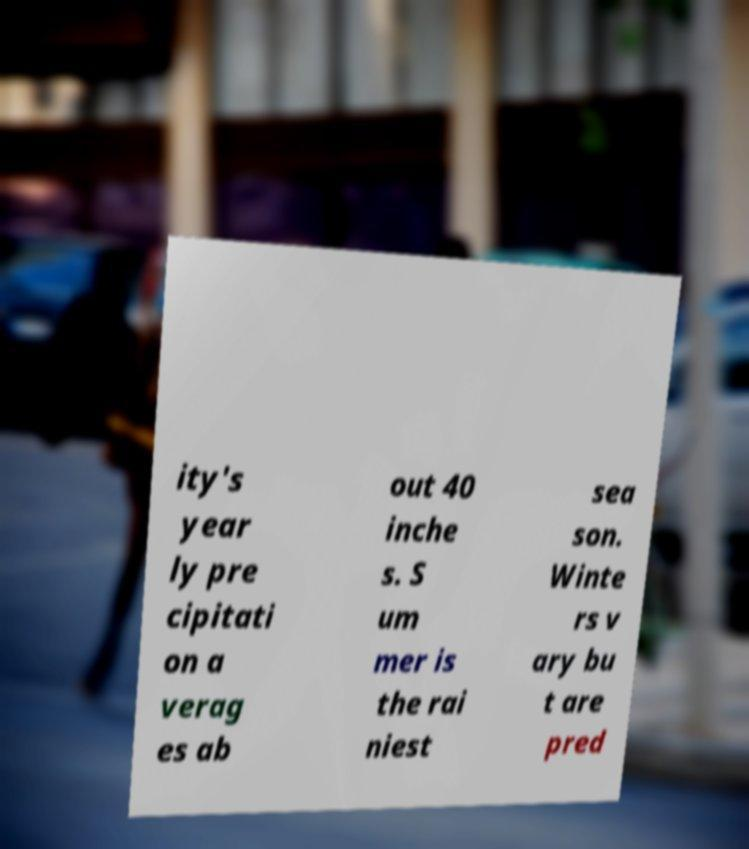There's text embedded in this image that I need extracted. Can you transcribe it verbatim? ity's year ly pre cipitati on a verag es ab out 40 inche s. S um mer is the rai niest sea son. Winte rs v ary bu t are pred 